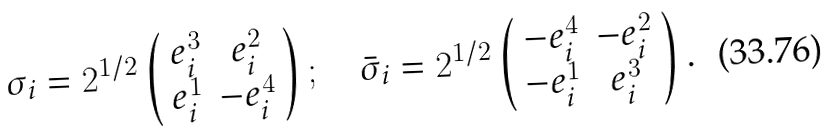Convert formula to latex. <formula><loc_0><loc_0><loc_500><loc_500>\sigma _ { i } = 2 ^ { 1 / 2 } \left ( \begin{array} { c c } e ^ { 3 } _ { i } & e ^ { 2 } _ { i } \\ e ^ { 1 } _ { i } & - e ^ { 4 } _ { i } \end{array} \right ) ; \quad \bar { \sigma } _ { i } = 2 ^ { 1 / 2 } \left ( \begin{array} { c c } - e ^ { 4 } _ { i } & - e ^ { 2 } _ { i } \\ - e ^ { 1 } _ { i } & e ^ { 3 } _ { i } \end{array} \right ) .</formula> 